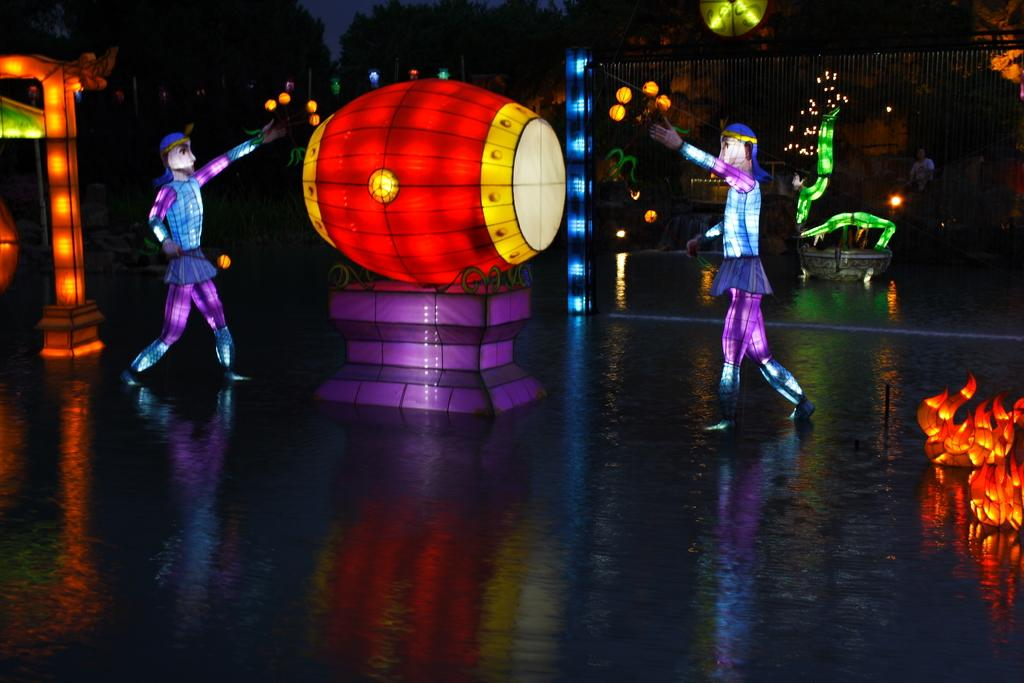How many people are on stage in the image? There are two people standing on stage in the image. What instrument can be seen on the stage? There is a musical drum on the stage. What can be seen in the background of the image? There are lights and other unspecified things in the background. What type of lipstick is the person on stage wearing in the image? There is no information about lipstick or any cosmetics in the image, as it focuses on the people and the musical drum on stage. Is there an oven visible in the image? No, there is no oven present in the image. 